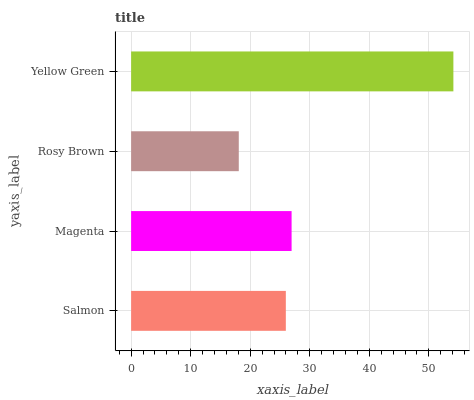Is Rosy Brown the minimum?
Answer yes or no. Yes. Is Yellow Green the maximum?
Answer yes or no. Yes. Is Magenta the minimum?
Answer yes or no. No. Is Magenta the maximum?
Answer yes or no. No. Is Magenta greater than Salmon?
Answer yes or no. Yes. Is Salmon less than Magenta?
Answer yes or no. Yes. Is Salmon greater than Magenta?
Answer yes or no. No. Is Magenta less than Salmon?
Answer yes or no. No. Is Magenta the high median?
Answer yes or no. Yes. Is Salmon the low median?
Answer yes or no. Yes. Is Salmon the high median?
Answer yes or no. No. Is Magenta the low median?
Answer yes or no. No. 